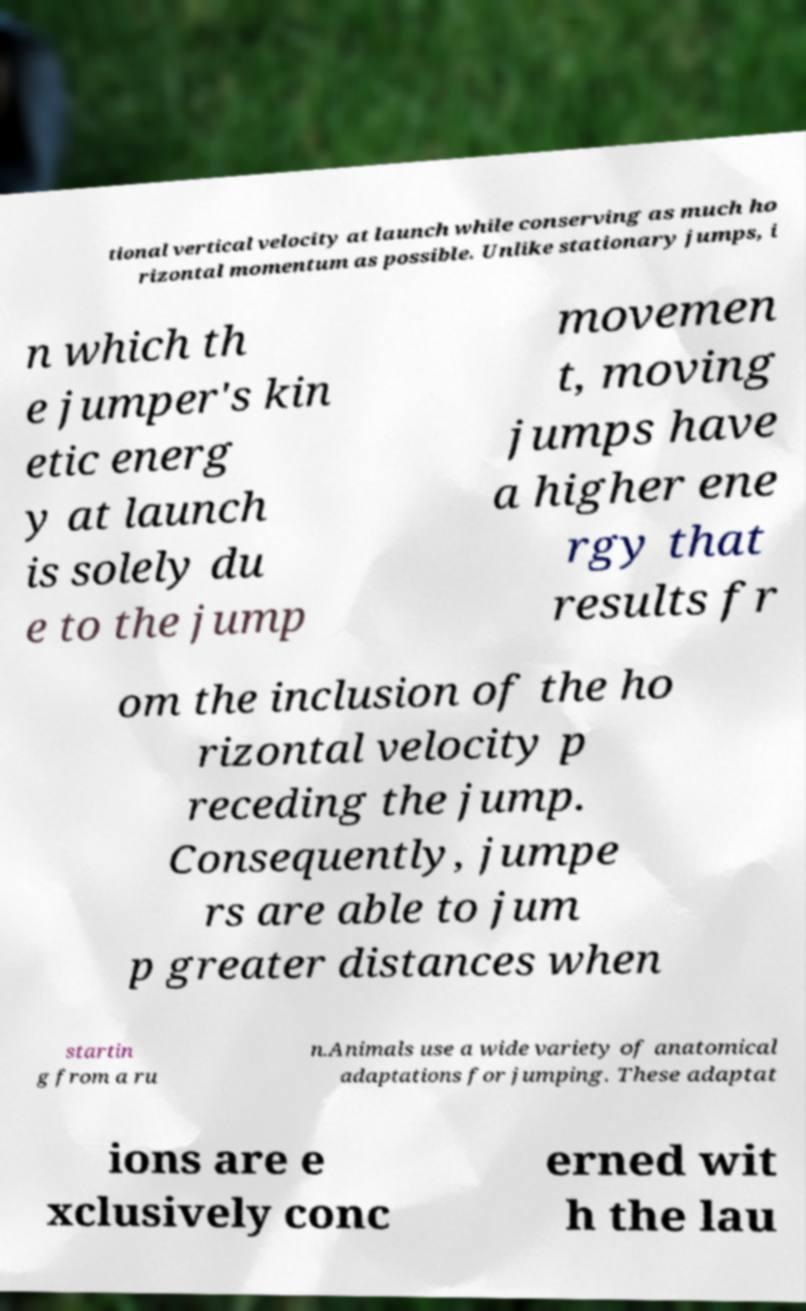Please read and relay the text visible in this image. What does it say? tional vertical velocity at launch while conserving as much ho rizontal momentum as possible. Unlike stationary jumps, i n which th e jumper's kin etic energ y at launch is solely du e to the jump movemen t, moving jumps have a higher ene rgy that results fr om the inclusion of the ho rizontal velocity p receding the jump. Consequently, jumpe rs are able to jum p greater distances when startin g from a ru n.Animals use a wide variety of anatomical adaptations for jumping. These adaptat ions are e xclusively conc erned wit h the lau 